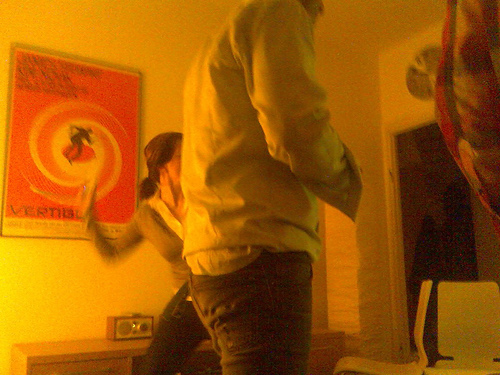What's happening in the image? It looks like a social gathering in a room with a lively atmosphere. One person is standing up as if in mid-motion, contributing to the dynamic feel of the scene. What objects can you identify in the background? In the background, there is a vibrant red poster with an image on it, a small black table or stand, and what appears to be a music speaker on top of the stand. 